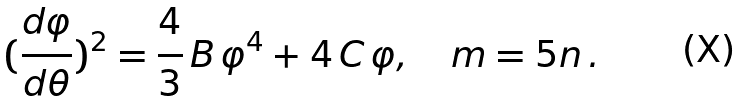Convert formula to latex. <formula><loc_0><loc_0><loc_500><loc_500>( \frac { d \varphi } { d \theta } ) ^ { 2 } = \frac { 4 } { 3 } \, B \, \varphi ^ { 4 } + 4 \, C \, \varphi , \quad m = 5 n \, .</formula> 